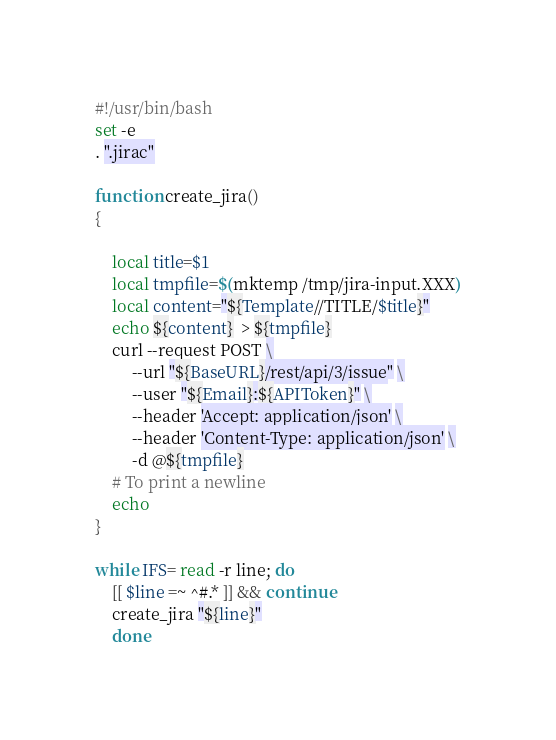Convert code to text. <code><loc_0><loc_0><loc_500><loc_500><_Bash_>#!/usr/bin/bash
set -e
. ".jirac"

function create_jira()
{

    local title=$1
    local tmpfile=$(mktemp /tmp/jira-input.XXX)
    local content="${Template//TITLE/$title}"
    echo ${content}  > ${tmpfile}
    curl --request POST \
         --url "${BaseURL}/rest/api/3/issue" \
         --user "${Email}:${APIToken}" \
         --header 'Accept: application/json' \
         --header 'Content-Type: application/json' \
         -d @${tmpfile}
    # To print a newline
    echo
}

while IFS= read -r line; do
    [[ $line =~ ^#.* ]] && continue
    create_jira "${line}"
    done
</code> 